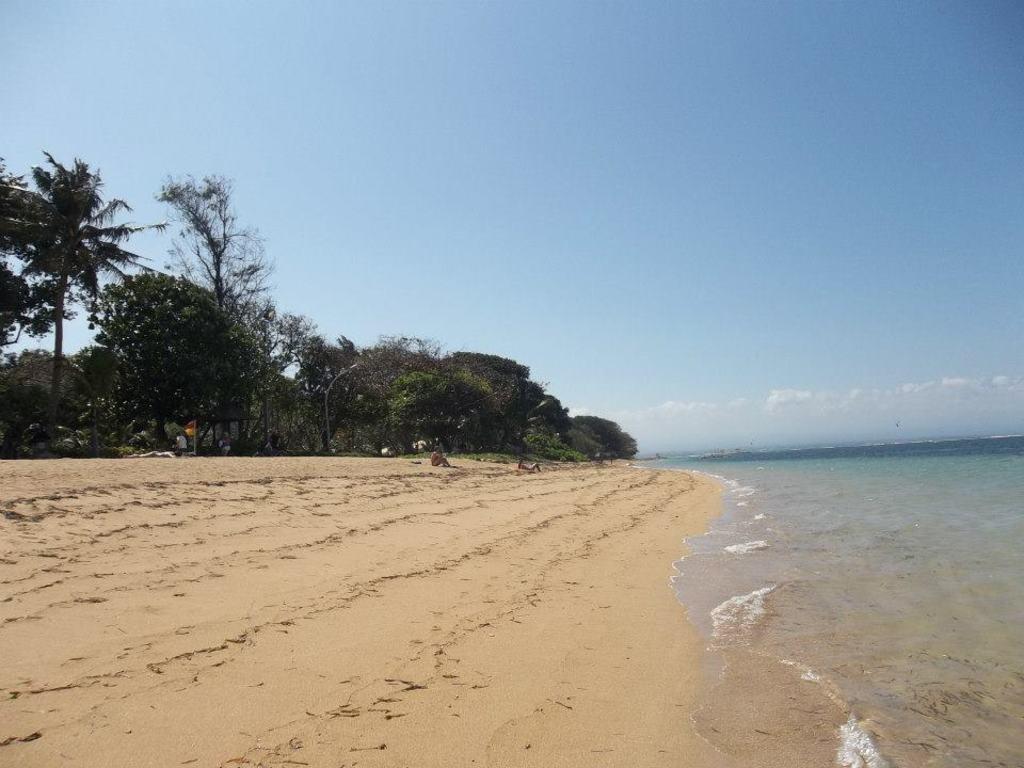How would you summarize this image in a sentence or two? In this picture we can see some people on sand, flag, trees, water and in the background we can see the sky with clouds. 